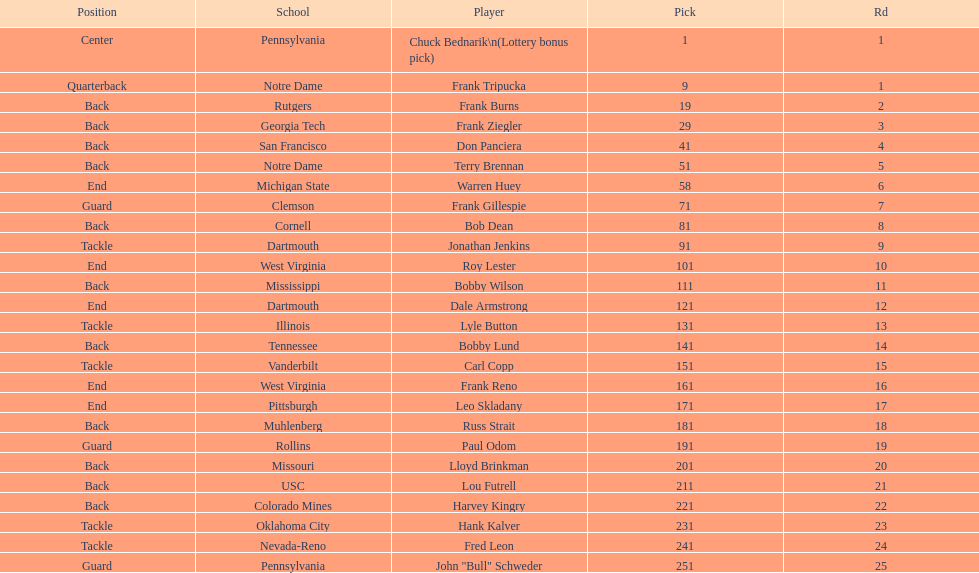Between frank tripucka and dale armstrong, how many draft picks were made? 10. 